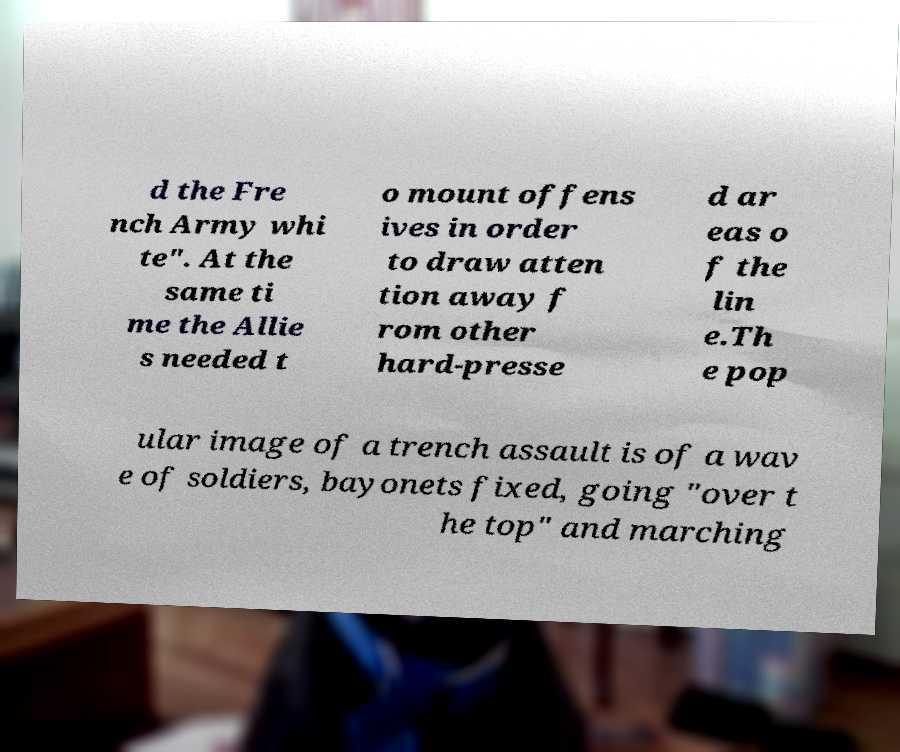I need the written content from this picture converted into text. Can you do that? d the Fre nch Army whi te". At the same ti me the Allie s needed t o mount offens ives in order to draw atten tion away f rom other hard-presse d ar eas o f the lin e.Th e pop ular image of a trench assault is of a wav e of soldiers, bayonets fixed, going "over t he top" and marching 